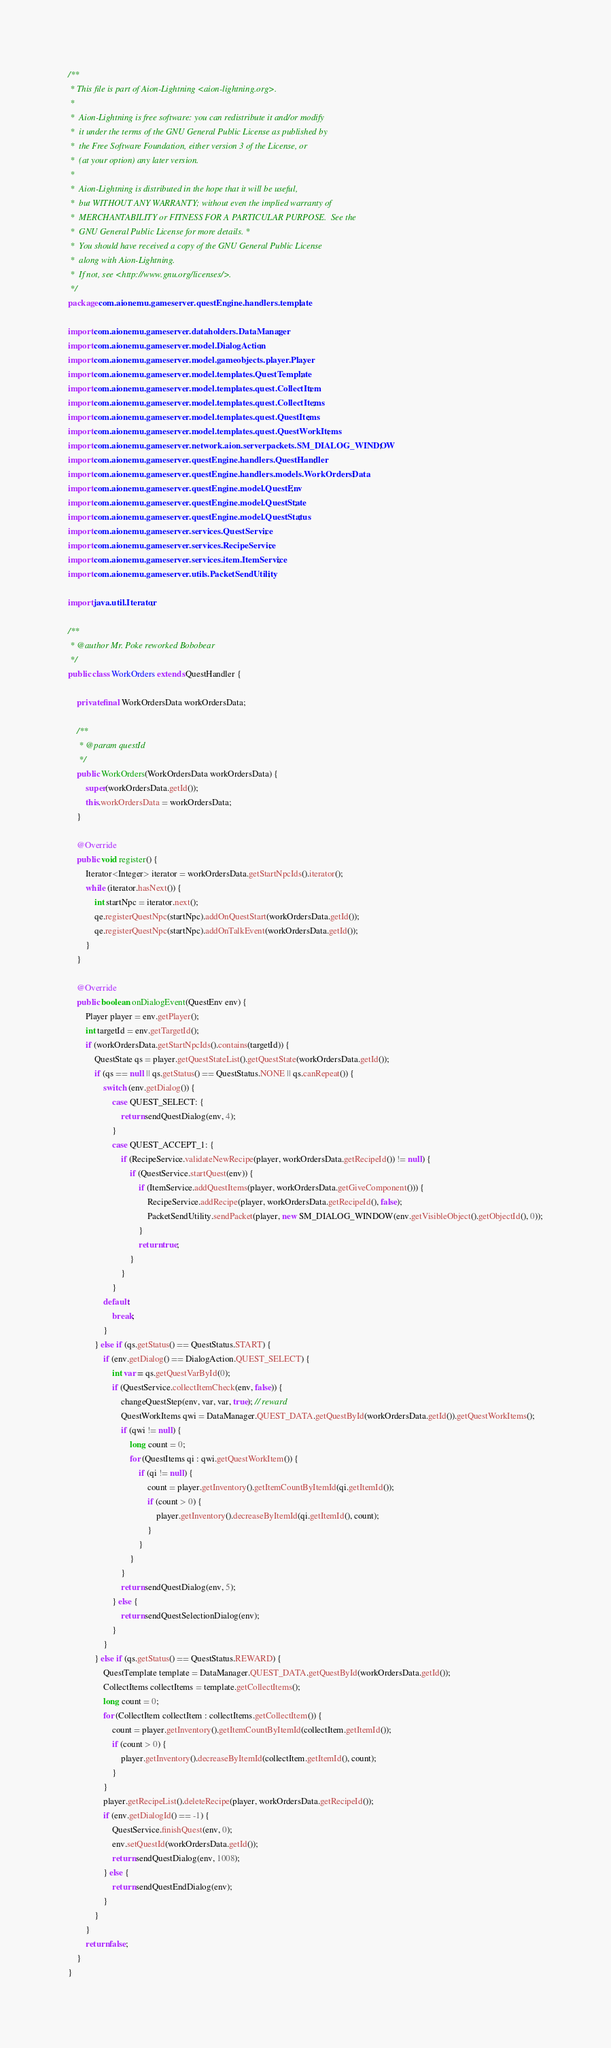Convert code to text. <code><loc_0><loc_0><loc_500><loc_500><_Java_>/**
 * This file is part of Aion-Lightning <aion-lightning.org>.
 *
 *  Aion-Lightning is free software: you can redistribute it and/or modify
 *  it under the terms of the GNU General Public License as published by
 *  the Free Software Foundation, either version 3 of the License, or
 *  (at your option) any later version.
 *
 *  Aion-Lightning is distributed in the hope that it will be useful,
 *  but WITHOUT ANY WARRANTY; without even the implied warranty of
 *  MERCHANTABILITY or FITNESS FOR A PARTICULAR PURPOSE.  See the
 *  GNU General Public License for more details. *
 *  You should have received a copy of the GNU General Public License
 *  along with Aion-Lightning.
 *  If not, see <http://www.gnu.org/licenses/>.
 */
package com.aionemu.gameserver.questEngine.handlers.template;

import com.aionemu.gameserver.dataholders.DataManager;
import com.aionemu.gameserver.model.DialogAction;
import com.aionemu.gameserver.model.gameobjects.player.Player;
import com.aionemu.gameserver.model.templates.QuestTemplate;
import com.aionemu.gameserver.model.templates.quest.CollectItem;
import com.aionemu.gameserver.model.templates.quest.CollectItems;
import com.aionemu.gameserver.model.templates.quest.QuestItems;
import com.aionemu.gameserver.model.templates.quest.QuestWorkItems;
import com.aionemu.gameserver.network.aion.serverpackets.SM_DIALOG_WINDOW;
import com.aionemu.gameserver.questEngine.handlers.QuestHandler;
import com.aionemu.gameserver.questEngine.handlers.models.WorkOrdersData;
import com.aionemu.gameserver.questEngine.model.QuestEnv;
import com.aionemu.gameserver.questEngine.model.QuestState;
import com.aionemu.gameserver.questEngine.model.QuestStatus;
import com.aionemu.gameserver.services.QuestService;
import com.aionemu.gameserver.services.RecipeService;
import com.aionemu.gameserver.services.item.ItemService;
import com.aionemu.gameserver.utils.PacketSendUtility;

import java.util.Iterator;

/**
 * @author Mr. Poke reworked Bobobear
 */
public class WorkOrders extends QuestHandler {

    private final WorkOrdersData workOrdersData;

    /**
     * @param questId
     */
    public WorkOrders(WorkOrdersData workOrdersData) {
        super(workOrdersData.getId());
        this.workOrdersData = workOrdersData;
    }

    @Override
    public void register() {
        Iterator<Integer> iterator = workOrdersData.getStartNpcIds().iterator();
        while (iterator.hasNext()) {
            int startNpc = iterator.next();
            qe.registerQuestNpc(startNpc).addOnQuestStart(workOrdersData.getId());
            qe.registerQuestNpc(startNpc).addOnTalkEvent(workOrdersData.getId());
        }
    }

    @Override
    public boolean onDialogEvent(QuestEnv env) {
        Player player = env.getPlayer();
        int targetId = env.getTargetId();
        if (workOrdersData.getStartNpcIds().contains(targetId)) {
            QuestState qs = player.getQuestStateList().getQuestState(workOrdersData.getId());
            if (qs == null || qs.getStatus() == QuestStatus.NONE || qs.canRepeat()) {
                switch (env.getDialog()) {
                    case QUEST_SELECT: {
                        return sendQuestDialog(env, 4);
                    }
                    case QUEST_ACCEPT_1: {
                        if (RecipeService.validateNewRecipe(player, workOrdersData.getRecipeId()) != null) {
                            if (QuestService.startQuest(env)) {
                                if (ItemService.addQuestItems(player, workOrdersData.getGiveComponent())) {
                                    RecipeService.addRecipe(player, workOrdersData.getRecipeId(), false);
                                    PacketSendUtility.sendPacket(player, new SM_DIALOG_WINDOW(env.getVisibleObject().getObjectId(), 0));
                                }
                                return true;
                            }
                        }
                    }
				default:
					break;
                }
            } else if (qs.getStatus() == QuestStatus.START) {
                if (env.getDialog() == DialogAction.QUEST_SELECT) {
                    int var = qs.getQuestVarById(0);
                    if (QuestService.collectItemCheck(env, false)) {
                        changeQuestStep(env, var, var, true); // reward
                        QuestWorkItems qwi = DataManager.QUEST_DATA.getQuestById(workOrdersData.getId()).getQuestWorkItems();
                        if (qwi != null) {
                            long count = 0;
                            for (QuestItems qi : qwi.getQuestWorkItem()) {
                                if (qi != null) {
                                    count = player.getInventory().getItemCountByItemId(qi.getItemId());
                                    if (count > 0) {
                                        player.getInventory().decreaseByItemId(qi.getItemId(), count);
                                    }
                                }
                            }
                        }
                        return sendQuestDialog(env, 5);
                    } else {
                        return sendQuestSelectionDialog(env);
                    }
                }
            } else if (qs.getStatus() == QuestStatus.REWARD) {
                QuestTemplate template = DataManager.QUEST_DATA.getQuestById(workOrdersData.getId());
                CollectItems collectItems = template.getCollectItems();
                long count = 0;
                for (CollectItem collectItem : collectItems.getCollectItem()) {
                    count = player.getInventory().getItemCountByItemId(collectItem.getItemId());
                    if (count > 0) {
                        player.getInventory().decreaseByItemId(collectItem.getItemId(), count);
                    }
                }
                player.getRecipeList().deleteRecipe(player, workOrdersData.getRecipeId());
                if (env.getDialogId() == -1) {
                    QuestService.finishQuest(env, 0);
                    env.setQuestId(workOrdersData.getId());
                    return sendQuestDialog(env, 1008);
                } else {
                    return sendQuestEndDialog(env);
                }
            }
        }
        return false;
    }
}
</code> 